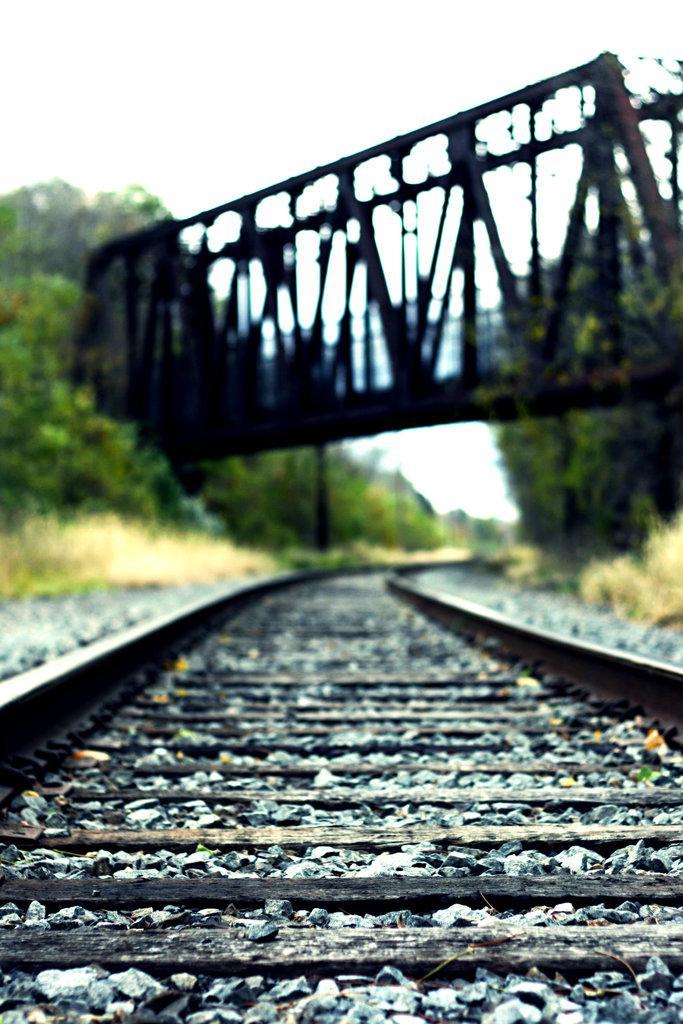Could you give a brief overview of what you see in this image? In this image I can see number of stones and few railway tracks in the front. In the background I can see number of trees and a bridge over these railway tracks. I can also see this image is blurry in the background. 